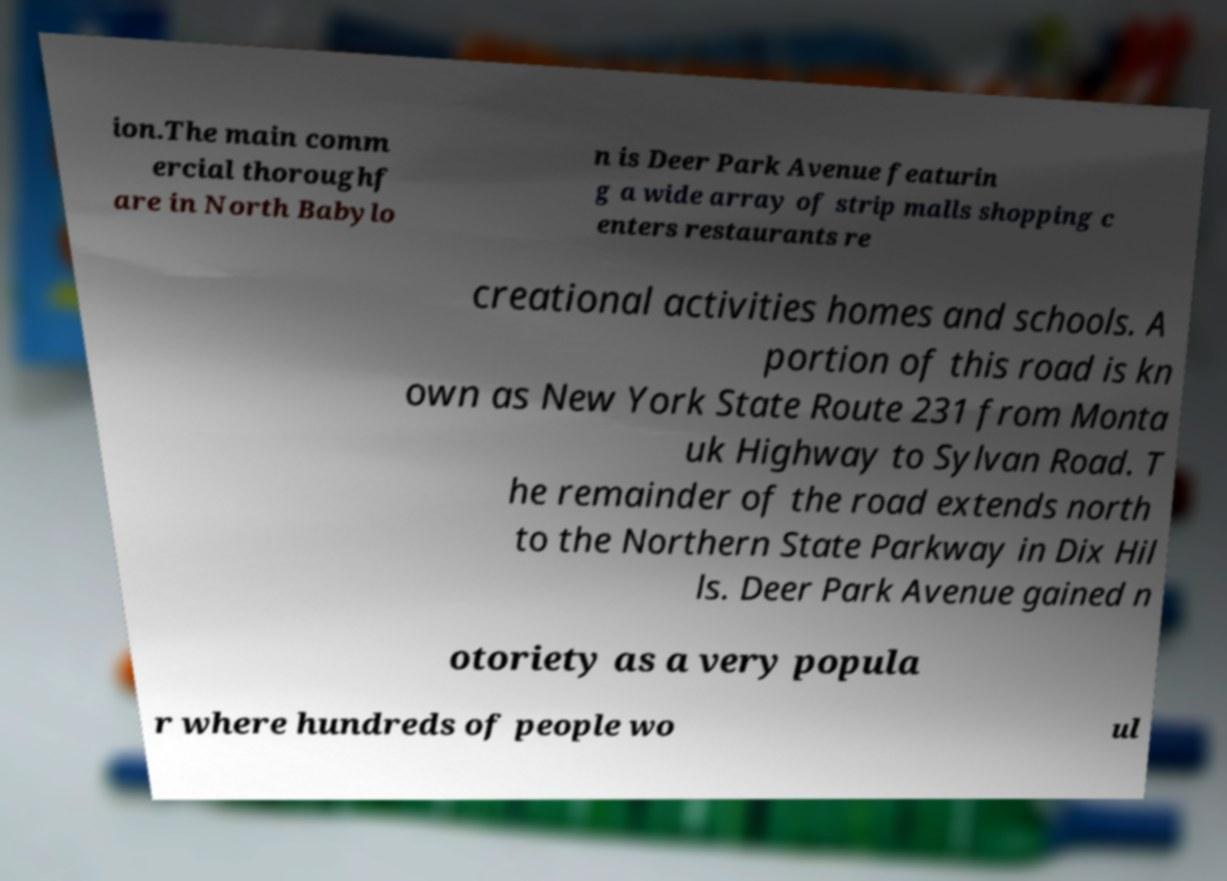Can you accurately transcribe the text from the provided image for me? ion.The main comm ercial thoroughf are in North Babylo n is Deer Park Avenue featurin g a wide array of strip malls shopping c enters restaurants re creational activities homes and schools. A portion of this road is kn own as New York State Route 231 from Monta uk Highway to Sylvan Road. T he remainder of the road extends north to the Northern State Parkway in Dix Hil ls. Deer Park Avenue gained n otoriety as a very popula r where hundreds of people wo ul 